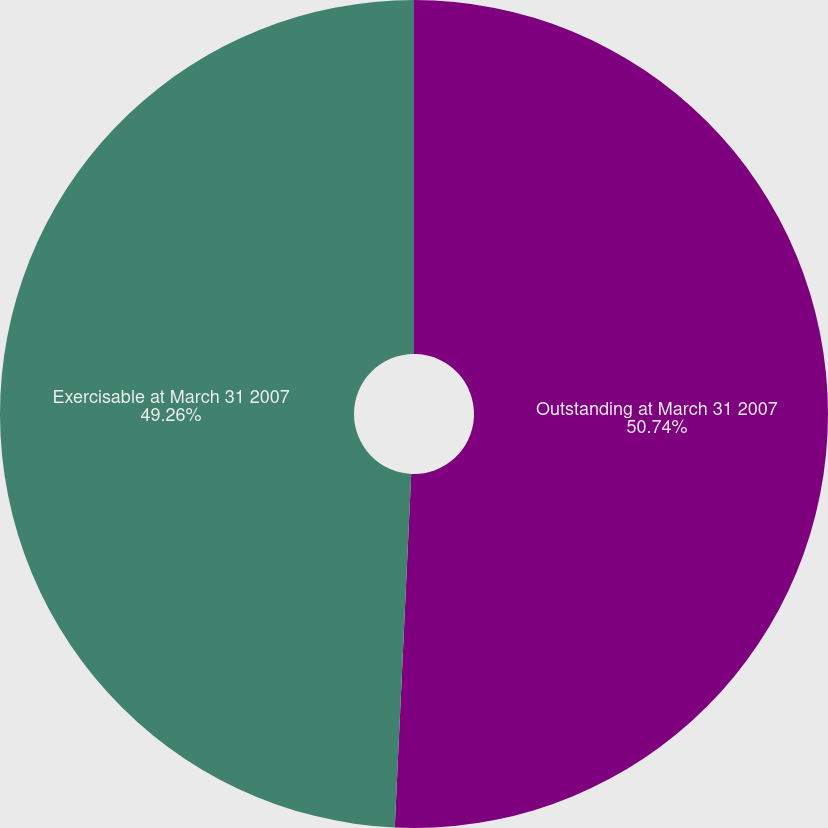Convert chart to OTSL. <chart><loc_0><loc_0><loc_500><loc_500><pie_chart><fcel>Outstanding at March 31 2007<fcel>Exercisable at March 31 2007<nl><fcel>50.74%<fcel>49.26%<nl></chart> 